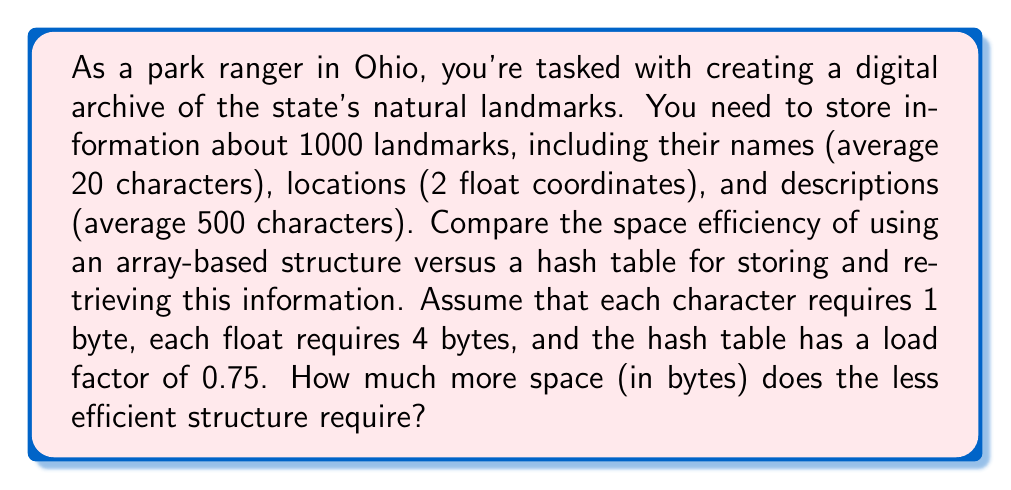What is the answer to this math problem? Let's break this down step-by-step:

1. Calculate the space required for each landmark:
   - Name: 20 characters * 1 byte = 20 bytes
   - Location: 2 floats * 4 bytes = 8 bytes
   - Description: 500 characters * 1 byte = 500 bytes
   Total per landmark: 20 + 8 + 500 = 528 bytes

2. Array-based structure:
   - Space required = Number of landmarks * Space per landmark
   - Space required = 1000 * 528 = 528,000 bytes

3. Hash table:
   - Number of buckets = Number of landmarks / Load factor
   - Number of buckets = 1000 / 0.75 ≈ 1334 (rounded up)
   - Each bucket requires a pointer (assume 8 bytes for 64-bit system)
   - Space for buckets = 1334 * 8 = 10,672 bytes
   - Space for data = 1000 * 528 = 528,000 bytes
   - Total space = 10,672 + 528,000 = 538,672 bytes

4. Difference in space:
   $$ \text{Difference} = 538,672 - 528,000 = 10,672 \text{ bytes} $$

The hash table requires 10,672 bytes more than the array-based structure.
Answer: 10,672 bytes 